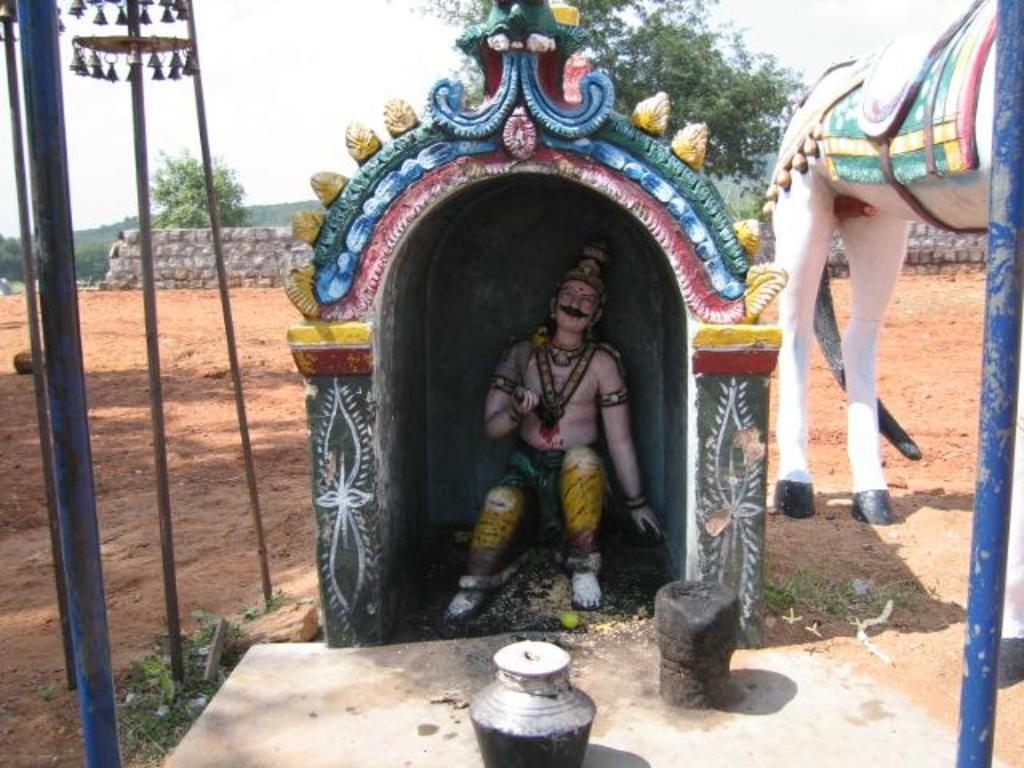Could you give a brief overview of what you see in this image? There is a statue under a roof and there is another statue of an animal and there are trees and a fence wall in the background. 